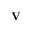<formula> <loc_0><loc_0><loc_500><loc_500>V</formula> 